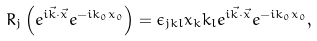<formula> <loc_0><loc_0><loc_500><loc_500>R _ { j } \left ( e ^ { i \vec { k } \cdot \vec { x } } e ^ { - i k _ { 0 } x _ { 0 } } \right ) = \epsilon _ { j k l } x _ { k } k _ { l } e ^ { i \vec { k } \cdot \vec { x } } e ^ { - i k _ { 0 } x _ { 0 } } ,</formula> 